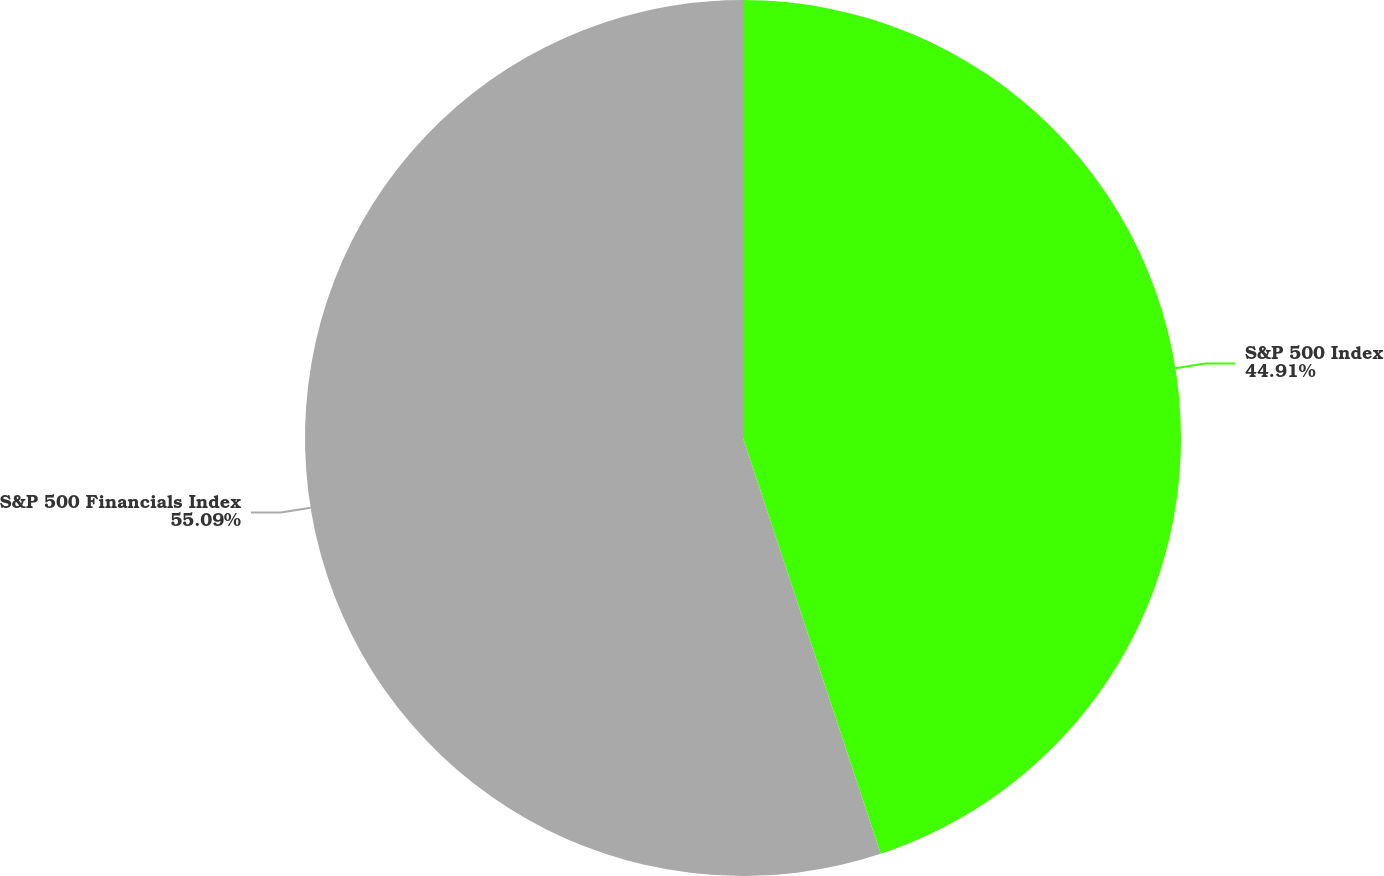Convert chart. <chart><loc_0><loc_0><loc_500><loc_500><pie_chart><fcel>S&P 500 Index<fcel>S&P 500 Financials Index<nl><fcel>44.91%<fcel>55.09%<nl></chart> 